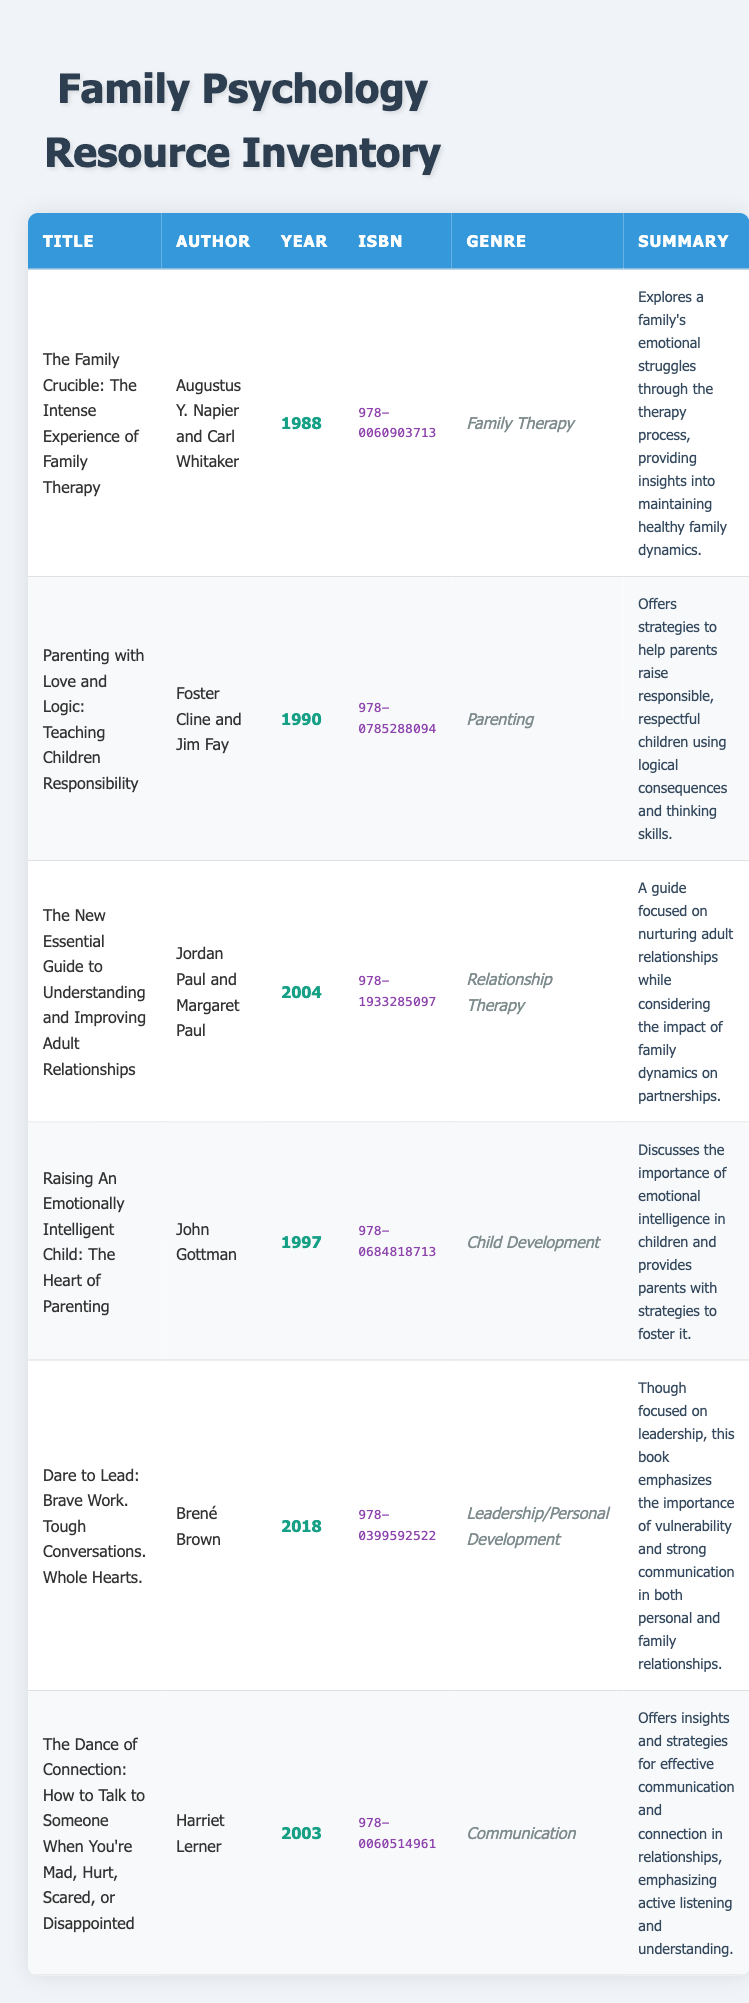What is the title of the oldest book in the inventory? The oldest book can be found by comparing the years listed. The book "The Family Crucible: The Intense Experience of Family Therapy" was published in 1988, which is earlier than any other listed year.
Answer: The Family Crucible: The Intense Experience of Family Therapy Who is the author of "Raising An Emotionally Intelligent Child: The Heart of Parenting"? This information can be found directly in the table under the author column for that specific book title. The author is listed as John Gottman.
Answer: John Gottman How many books in the inventory were published after 2000? A review of the years in the table shows that there are three books published after 2000: "The New Essential Guide to Understanding and Improving Adult Relationships" (2004), "Dare to Lead: Brave Work. Tough Conversations. Whole Hearts." (2018), and "The Dance of Connection" (2003). Therefore, the count is 3.
Answer: 3 Is "Dare to Lead" focused on family therapy? To determine this, we must look at the genre and summary. The genre states "Leadership/Personal Development" and the summary emphasizes communication in personal relationships but does not specifically mention family therapy. Hence, the answer is no.
Answer: No What are the genres of the books authored by Harriet Lerner and John Gottman? First, identify the authors in the table and their corresponding genres. Harriet Lerner authored "The Dance of Connection," which falls under "Communication," and John Gottman authored "Raising An Emotionally Intelligent Child," which is listed as "Child Development." Therefore, the genres are Communication and Child Development, respectively.
Answer: Communication and Child Development Which book discusses teaching logical consequences to children? The table shows that "Parenting with Love and Logic: Teaching Children Responsibility" by Foster Cline and Jim Fay specifically mentions teaching children responsibility using logical consequences in its summary.
Answer: Parenting with Love and Logic: Teaching Children Responsibility What is the total number of different genres represented in the inventory? By examining the genre column in the table, the distinct genres listed are Family Therapy, Parenting, Relationship Therapy, Child Development, Leadership/Personal Development, and Communication. This gives us a total of six unique genres.
Answer: 6 Which two books emphasize emotional intelligence and connection? From the table, "Raising An Emotionally Intelligent Child: The Heart of Parenting" explicitly discusses emotional intelligence. Moreover, "The Dance of Connection: How to Talk to Someone When You're Mad, Hurt, Scared, or Disappointed" emphasizes connection in relationships. Thus, these two books emphasize the stated themes.
Answer: Raising An Emotionally Intelligent Child and The Dance of Connection 